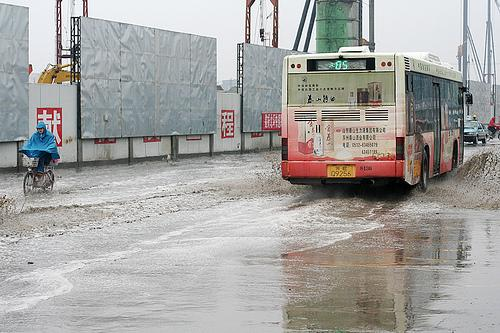Which object is in the greatest danger?

Choices:
A) bus
B) motorcyclist
C) blue car
D) cyclist cyclist 